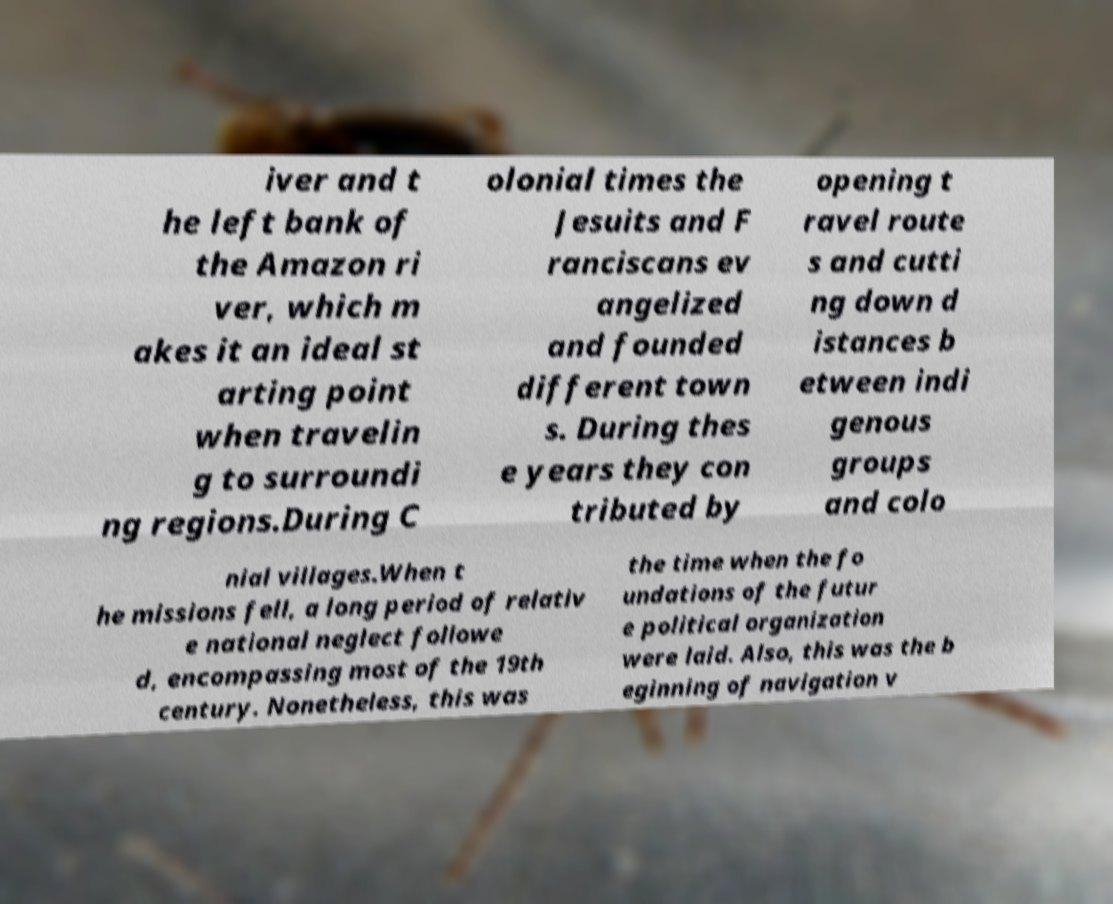Can you read and provide the text displayed in the image?This photo seems to have some interesting text. Can you extract and type it out for me? iver and t he left bank of the Amazon ri ver, which m akes it an ideal st arting point when travelin g to surroundi ng regions.During C olonial times the Jesuits and F ranciscans ev angelized and founded different town s. During thes e years they con tributed by opening t ravel route s and cutti ng down d istances b etween indi genous groups and colo nial villages.When t he missions fell, a long period of relativ e national neglect followe d, encompassing most of the 19th century. Nonetheless, this was the time when the fo undations of the futur e political organization were laid. Also, this was the b eginning of navigation v 